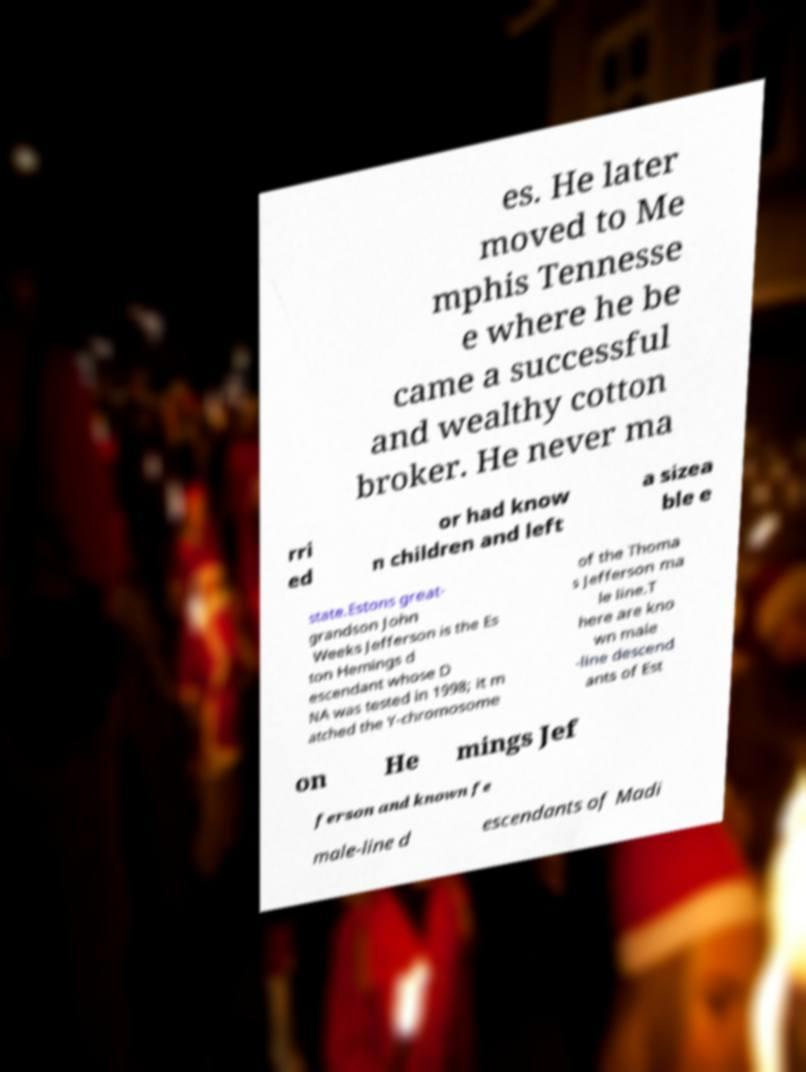I need the written content from this picture converted into text. Can you do that? es. He later moved to Me mphis Tennesse e where he be came a successful and wealthy cotton broker. He never ma rri ed or had know n children and left a sizea ble e state.Estons great- grandson John Weeks Jefferson is the Es ton Hemings d escendant whose D NA was tested in 1998; it m atched the Y-chromosome of the Thoma s Jefferson ma le line.T here are kno wn male -line descend ants of Est on He mings Jef ferson and known fe male-line d escendants of Madi 